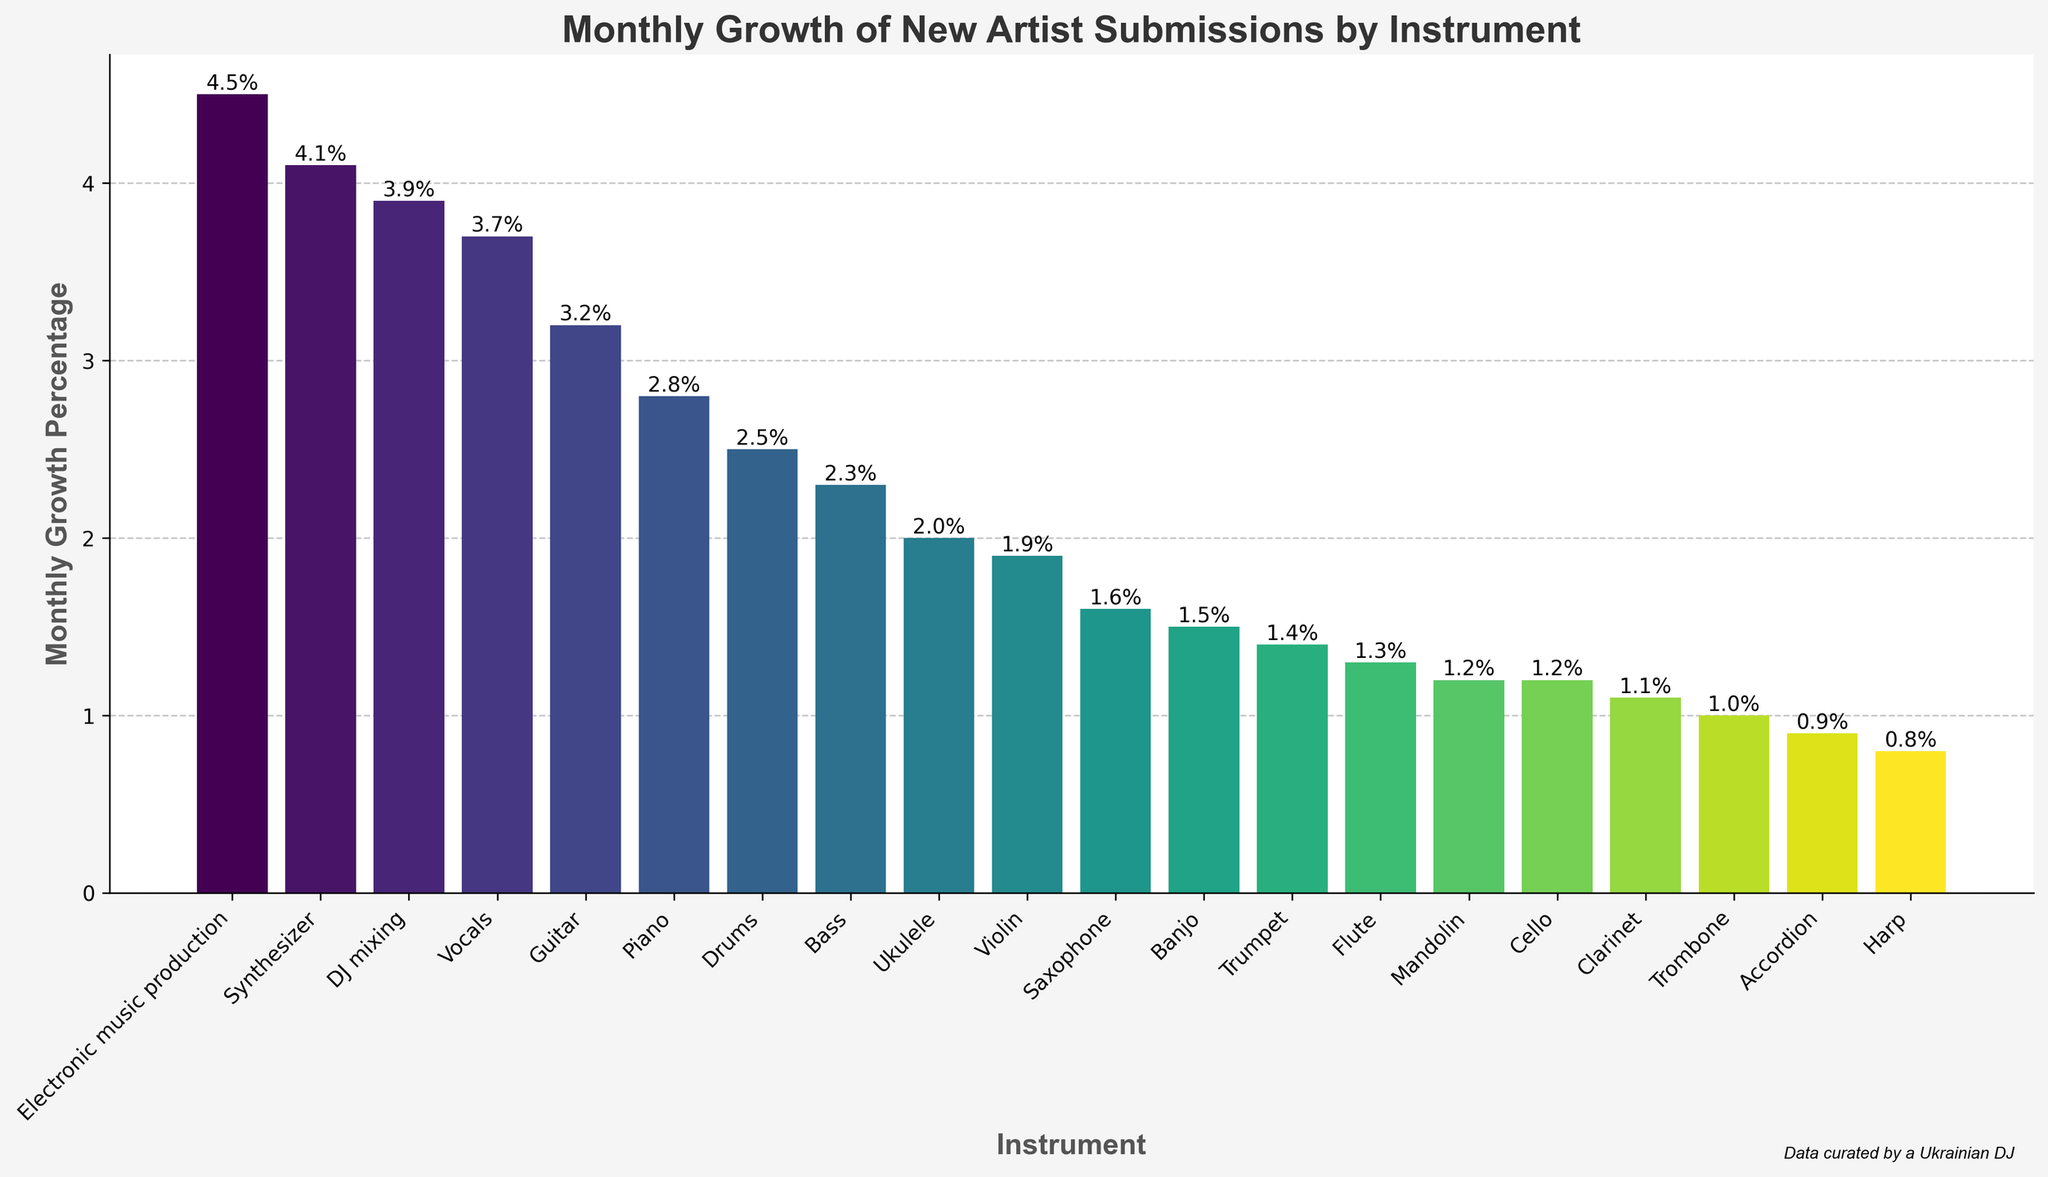Which instrument has the highest monthly growth percentage? By looking at the heights of all the bars, we can see that the bar for 'Electronic music production' is the tallest, indicating it has the highest monthly growth percentage.
Answer: Electronic music production Which two instruments have the closest monthly growth percentages? By visually comparing the bar heights, 'Clarinet' and 'Accordion' have very similar heights, indicating their monthly growth percentages are close.
Answer: Clarinet and Accordion What's the difference in monthly growth percentage between 'Guitar' and 'Piano'? Identify the heights of the bars for 'Guitar' (3.2%) and 'Piano' (2.8%) and subtract the smaller from the larger: 3.2% - 2.8% = 0.4%.
Answer: 0.4% Which instrument has a monthly growth percentage greater than 3.0% but less than 4.0%? Identify bars with heights between 3.0% and 4.0%. 'Guitar', 'Vocals', and 'DJ mixing' fit this criteria.
Answer: Guitar, Vocals, and DJ mixing What's the combined monthly growth percentage of 'Violin', 'Flute', and 'Clarinet'? Add the growth percentages for 'Violin' (1.9%), 'Flute' (1.3%), and 'Clarinet' (1.1%): 1.9% + 1.3% + 1.1% = 4.3%.
Answer: 4.3% Which instruments have a monthly growth percentage less than 2.0%? Identify bars with heights less than 2.0%. These are 'Violin', 'Saxophone', 'Trumpet', 'Cello', 'Flute', 'Clarinet', 'Accordion', 'Harp', 'Trombone', and 'Banjo'.
Answer: Violin, Saxophone, Trumpet, Cello, Flute, Clarinet, Accordion, Harp, Trombone, and Banjo How many instruments have a monthly growth percentage greater than 3.0%? Count the number of bars higher than 3.0%. These include 'Guitar', 'Vocals', 'Synthesizer', 'Electronic music production', and 'DJ mixing'.
Answer: 5 